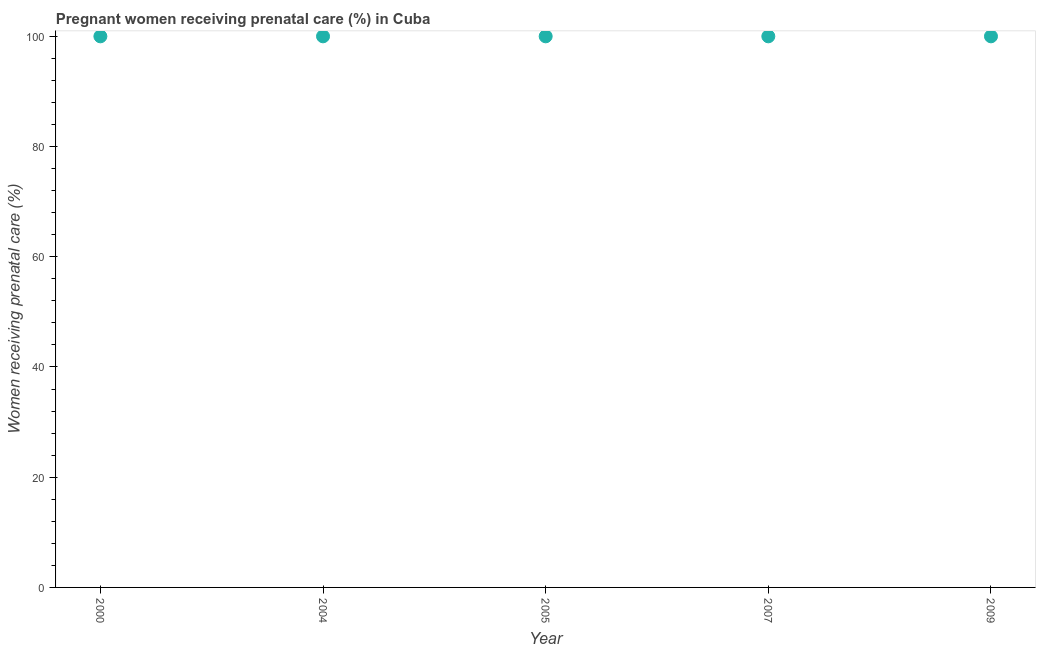What is the percentage of pregnant women receiving prenatal care in 2009?
Keep it short and to the point. 100. Across all years, what is the maximum percentage of pregnant women receiving prenatal care?
Provide a succinct answer. 100. Across all years, what is the minimum percentage of pregnant women receiving prenatal care?
Your answer should be very brief. 100. In which year was the percentage of pregnant women receiving prenatal care minimum?
Your answer should be very brief. 2000. What is the sum of the percentage of pregnant women receiving prenatal care?
Ensure brevity in your answer.  500. What is the difference between the percentage of pregnant women receiving prenatal care in 2004 and 2007?
Your answer should be compact. 0. What is the median percentage of pregnant women receiving prenatal care?
Make the answer very short. 100. In how many years, is the percentage of pregnant women receiving prenatal care greater than 40 %?
Ensure brevity in your answer.  5. Is the percentage of pregnant women receiving prenatal care in 2004 less than that in 2005?
Keep it short and to the point. No. Is the difference between the percentage of pregnant women receiving prenatal care in 2000 and 2005 greater than the difference between any two years?
Your response must be concise. Yes. What is the difference between the highest and the second highest percentage of pregnant women receiving prenatal care?
Offer a terse response. 0. Is the sum of the percentage of pregnant women receiving prenatal care in 2007 and 2009 greater than the maximum percentage of pregnant women receiving prenatal care across all years?
Offer a terse response. Yes. What is the difference between the highest and the lowest percentage of pregnant women receiving prenatal care?
Your answer should be compact. 0. Does the percentage of pregnant women receiving prenatal care monotonically increase over the years?
Your response must be concise. No. How many dotlines are there?
Provide a short and direct response. 1. How many years are there in the graph?
Provide a succinct answer. 5. What is the difference between two consecutive major ticks on the Y-axis?
Provide a succinct answer. 20. Does the graph contain grids?
Your answer should be compact. No. What is the title of the graph?
Your answer should be very brief. Pregnant women receiving prenatal care (%) in Cuba. What is the label or title of the X-axis?
Offer a very short reply. Year. What is the label or title of the Y-axis?
Your answer should be very brief. Women receiving prenatal care (%). What is the Women receiving prenatal care (%) in 2005?
Ensure brevity in your answer.  100. What is the Women receiving prenatal care (%) in 2007?
Give a very brief answer. 100. What is the Women receiving prenatal care (%) in 2009?
Give a very brief answer. 100. What is the difference between the Women receiving prenatal care (%) in 2000 and 2005?
Offer a very short reply. 0. What is the difference between the Women receiving prenatal care (%) in 2000 and 2009?
Ensure brevity in your answer.  0. What is the difference between the Women receiving prenatal care (%) in 2005 and 2007?
Provide a succinct answer. 0. What is the difference between the Women receiving prenatal care (%) in 2005 and 2009?
Give a very brief answer. 0. What is the ratio of the Women receiving prenatal care (%) in 2000 to that in 2004?
Ensure brevity in your answer.  1. What is the ratio of the Women receiving prenatal care (%) in 2000 to that in 2007?
Give a very brief answer. 1. What is the ratio of the Women receiving prenatal care (%) in 2004 to that in 2007?
Your answer should be compact. 1. What is the ratio of the Women receiving prenatal care (%) in 2004 to that in 2009?
Make the answer very short. 1. What is the ratio of the Women receiving prenatal care (%) in 2005 to that in 2007?
Provide a short and direct response. 1. What is the ratio of the Women receiving prenatal care (%) in 2005 to that in 2009?
Give a very brief answer. 1. What is the ratio of the Women receiving prenatal care (%) in 2007 to that in 2009?
Offer a terse response. 1. 